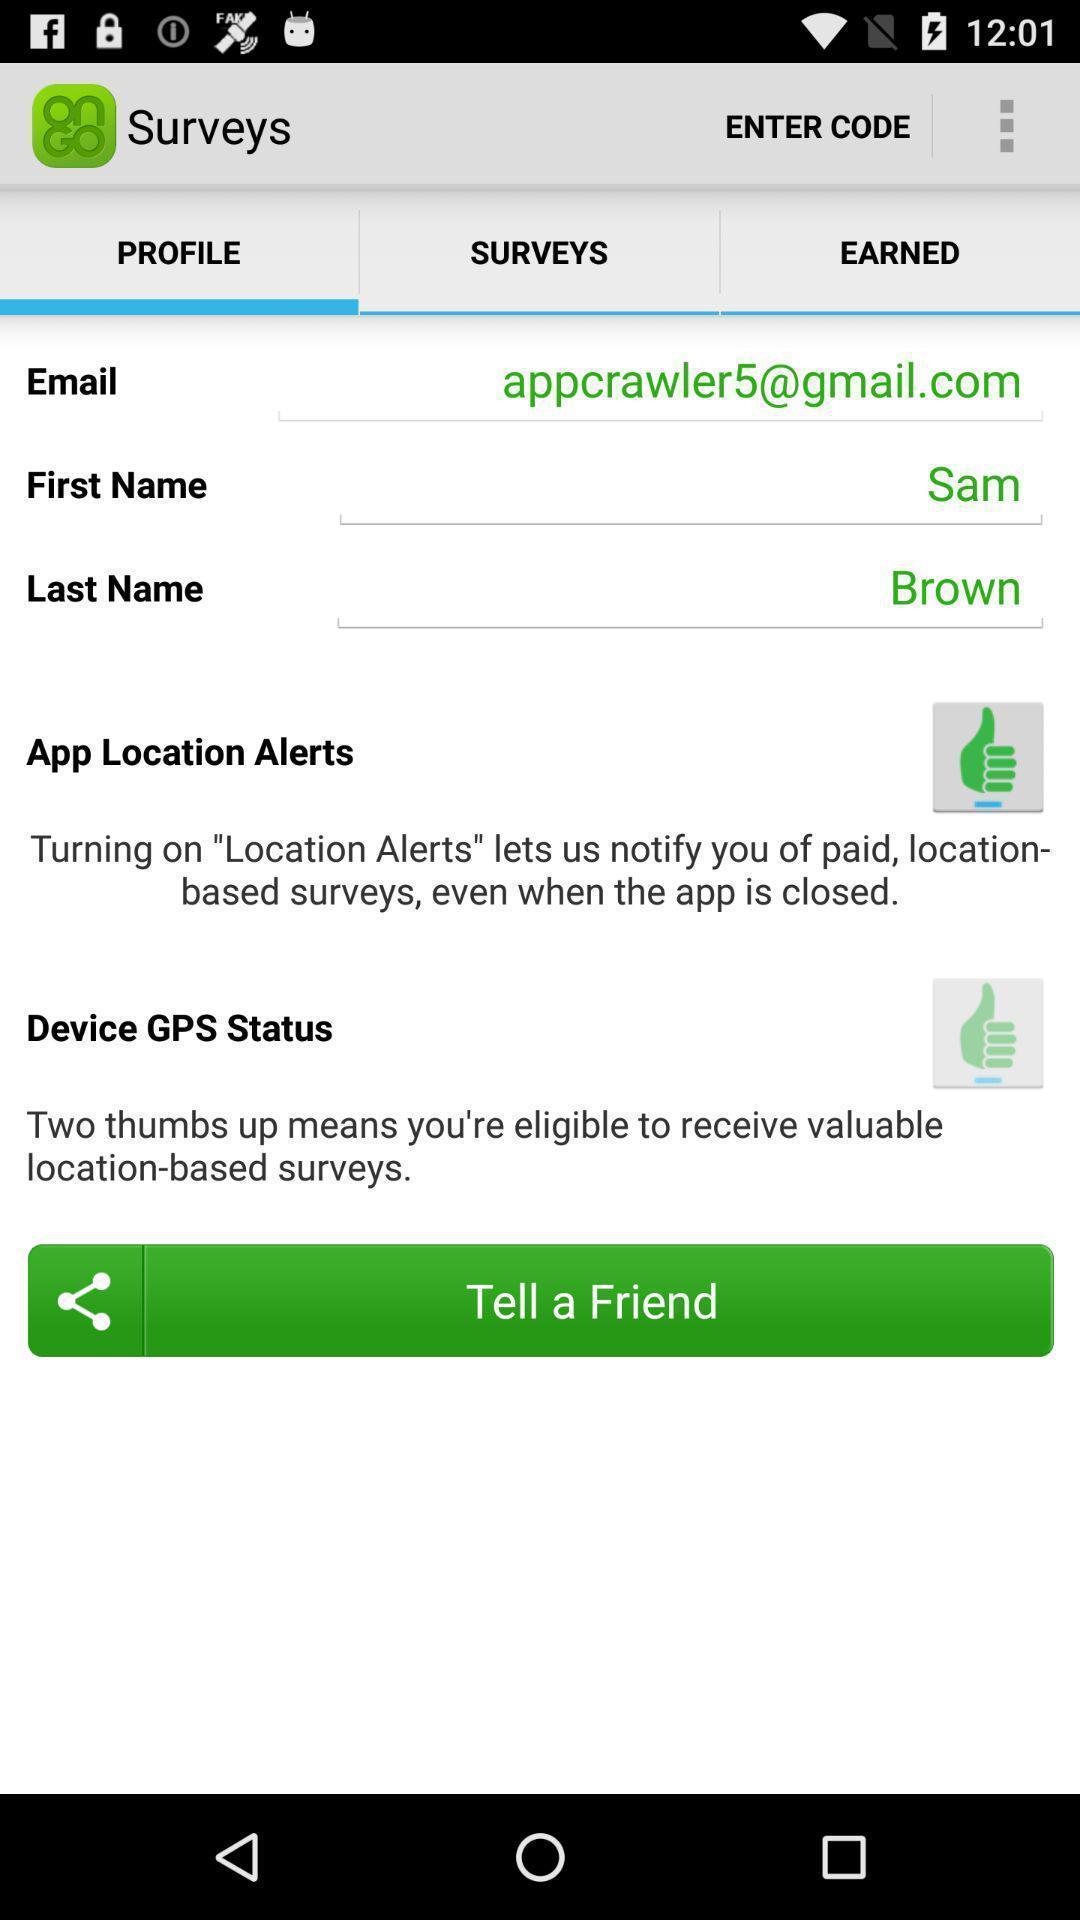Summarize the information in this screenshot. Page showing option like tell a friend. 